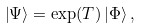Convert formula to latex. <formula><loc_0><loc_0><loc_500><loc_500>\left | \Psi \right \rangle = \exp ( T ) \left | \Phi \right \rangle ,</formula> 